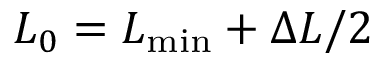Convert formula to latex. <formula><loc_0><loc_0><loc_500><loc_500>L _ { 0 } = L _ { \min } + \Delta L / 2</formula> 